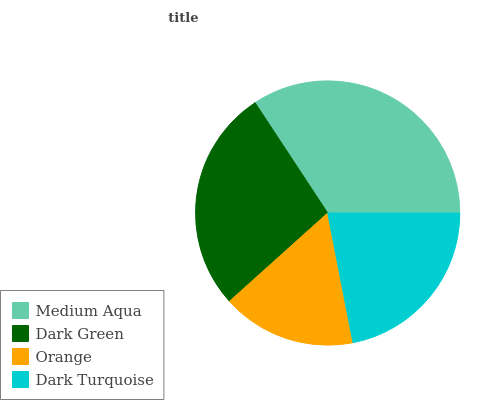Is Orange the minimum?
Answer yes or no. Yes. Is Medium Aqua the maximum?
Answer yes or no. Yes. Is Dark Green the minimum?
Answer yes or no. No. Is Dark Green the maximum?
Answer yes or no. No. Is Medium Aqua greater than Dark Green?
Answer yes or no. Yes. Is Dark Green less than Medium Aqua?
Answer yes or no. Yes. Is Dark Green greater than Medium Aqua?
Answer yes or no. No. Is Medium Aqua less than Dark Green?
Answer yes or no. No. Is Dark Green the high median?
Answer yes or no. Yes. Is Dark Turquoise the low median?
Answer yes or no. Yes. Is Dark Turquoise the high median?
Answer yes or no. No. Is Orange the low median?
Answer yes or no. No. 